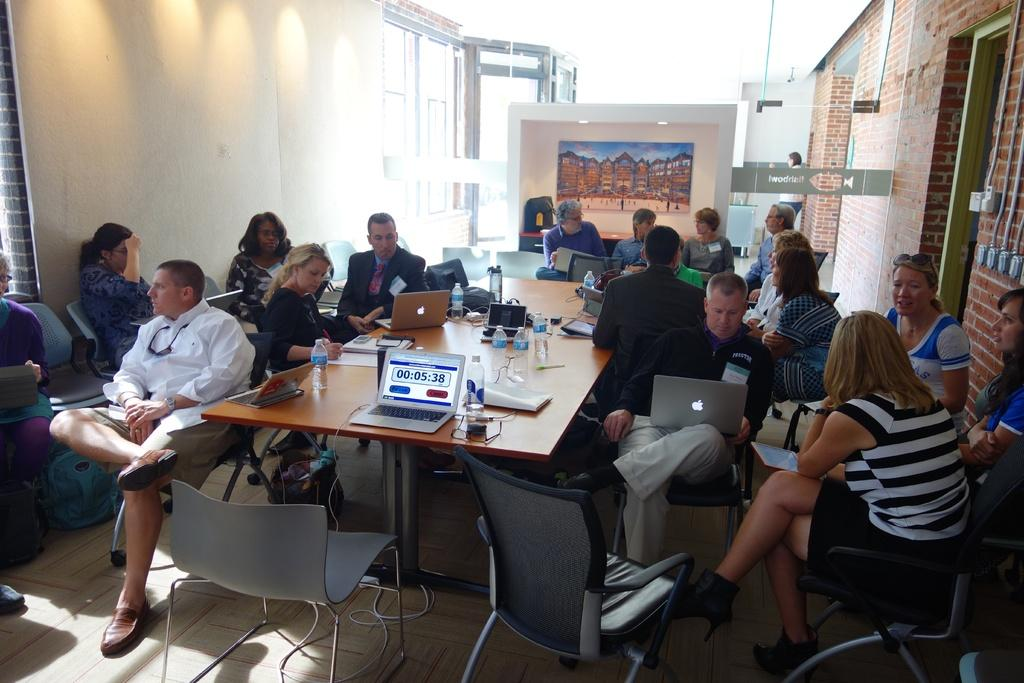How many people are in the image? There is a group of people in the image. What are the people doing in the image? The people are sitting in chairs. What objects do the people have with them? The people have laptops. What items can be seen on the table? There are bottles, papers, bags, and laptops on the table. What can be seen in the background of the image? There is a frame, a door, and lights in the background. What type of range can be seen in the image? There is no range present in the image. How many trucks are visible in the image? There are no trucks visible in the image. 